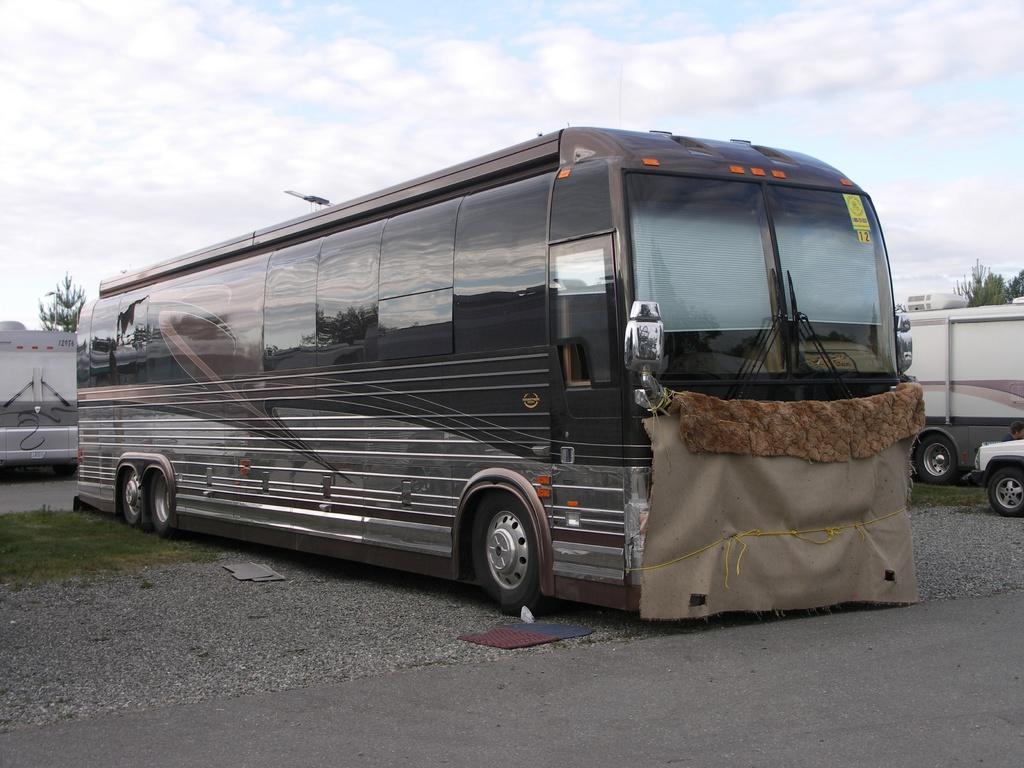Please provide a concise description of this image. In this image there is a bus and few vehicles are on the road. Left side there is grassland. Background there are few trees. Top of the image there is sky with some clouds. Front side of the image bus is covered with a cloth which is tied with a rope. 